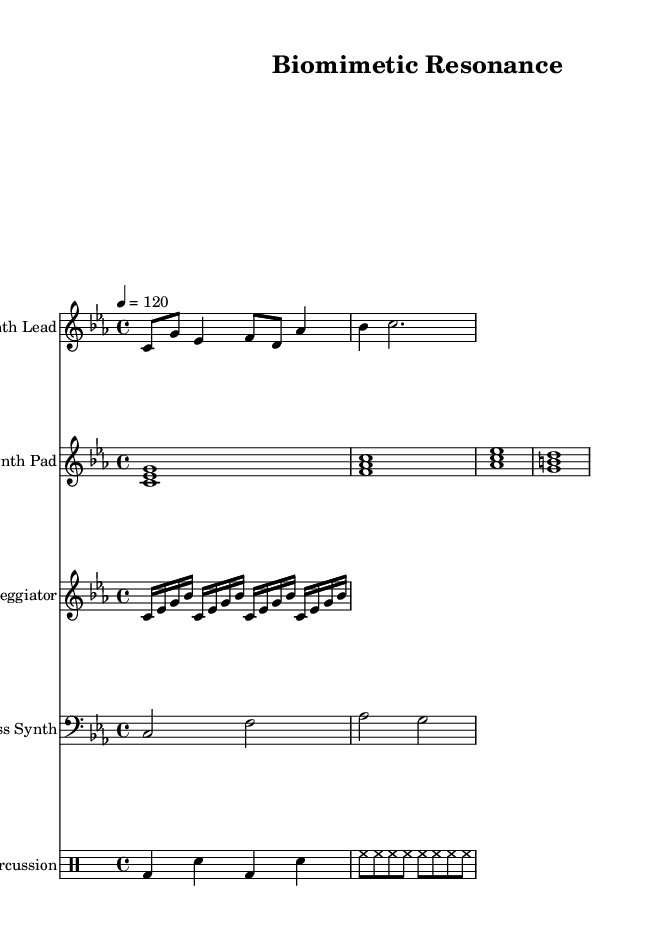What is the key signature of this music? The key signature indicated on the sheet music is C minor, which has three flats in the key signature (B flat, E flat, and A flat).
Answer: C minor What is the time signature of this piece? The time signature shown in the music is 4/4, meaning there are four beats in each measure, and the quarter note gets one beat.
Answer: 4/4 What is the tempo marking for the piece? The tempo marking given is "4 = 120", indicating that there are 120 beats per minute, making the piece moderate in pace.
Answer: 120 How many measures are in the Synth Lead staff? By analyzing the notes and bar lines on the Synth Lead staff, we can count a total of 4 measures present in this section of the sheet music.
Answer: 4 Which instruments are represented in this score? The score includes Synth Lead, Synth Pad, Arpeggiator, Bass Synth, and Percussion, which shows the various electronic sounds being utilized in this composition.
Answer: Synth Lead, Synth Pad, Arpeggiator, Bass Synth, Percussion What note starts the Synth Pad part and which voicing does it utilize? The Synth Pad part starts on the note C and utilizes three-note voicings for each chord, showcasing a fuller harmonic texture.
Answer: C and three-note voicings What type of sound is represented by the percussion section? The percussion section exhibits a combination of bass drums, snare, and hi-hats, which are typical components of an electronic music rhythm section, providing a driving beat.
Answer: Electronic rhythm 